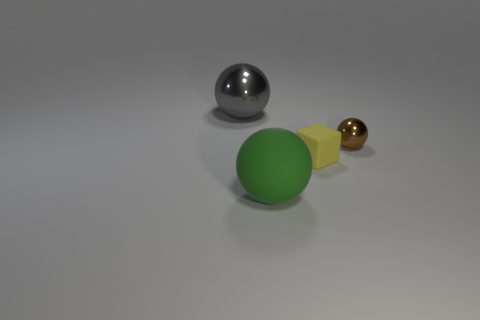Subtract all big spheres. How many spheres are left? 1 Add 3 big shiny things. How many objects exist? 7 Subtract all balls. How many objects are left? 1 Add 3 big yellow shiny spheres. How many big yellow shiny spheres exist? 3 Subtract 0 gray cubes. How many objects are left? 4 Subtract all brown spheres. Subtract all matte things. How many objects are left? 1 Add 4 big rubber balls. How many big rubber balls are left? 5 